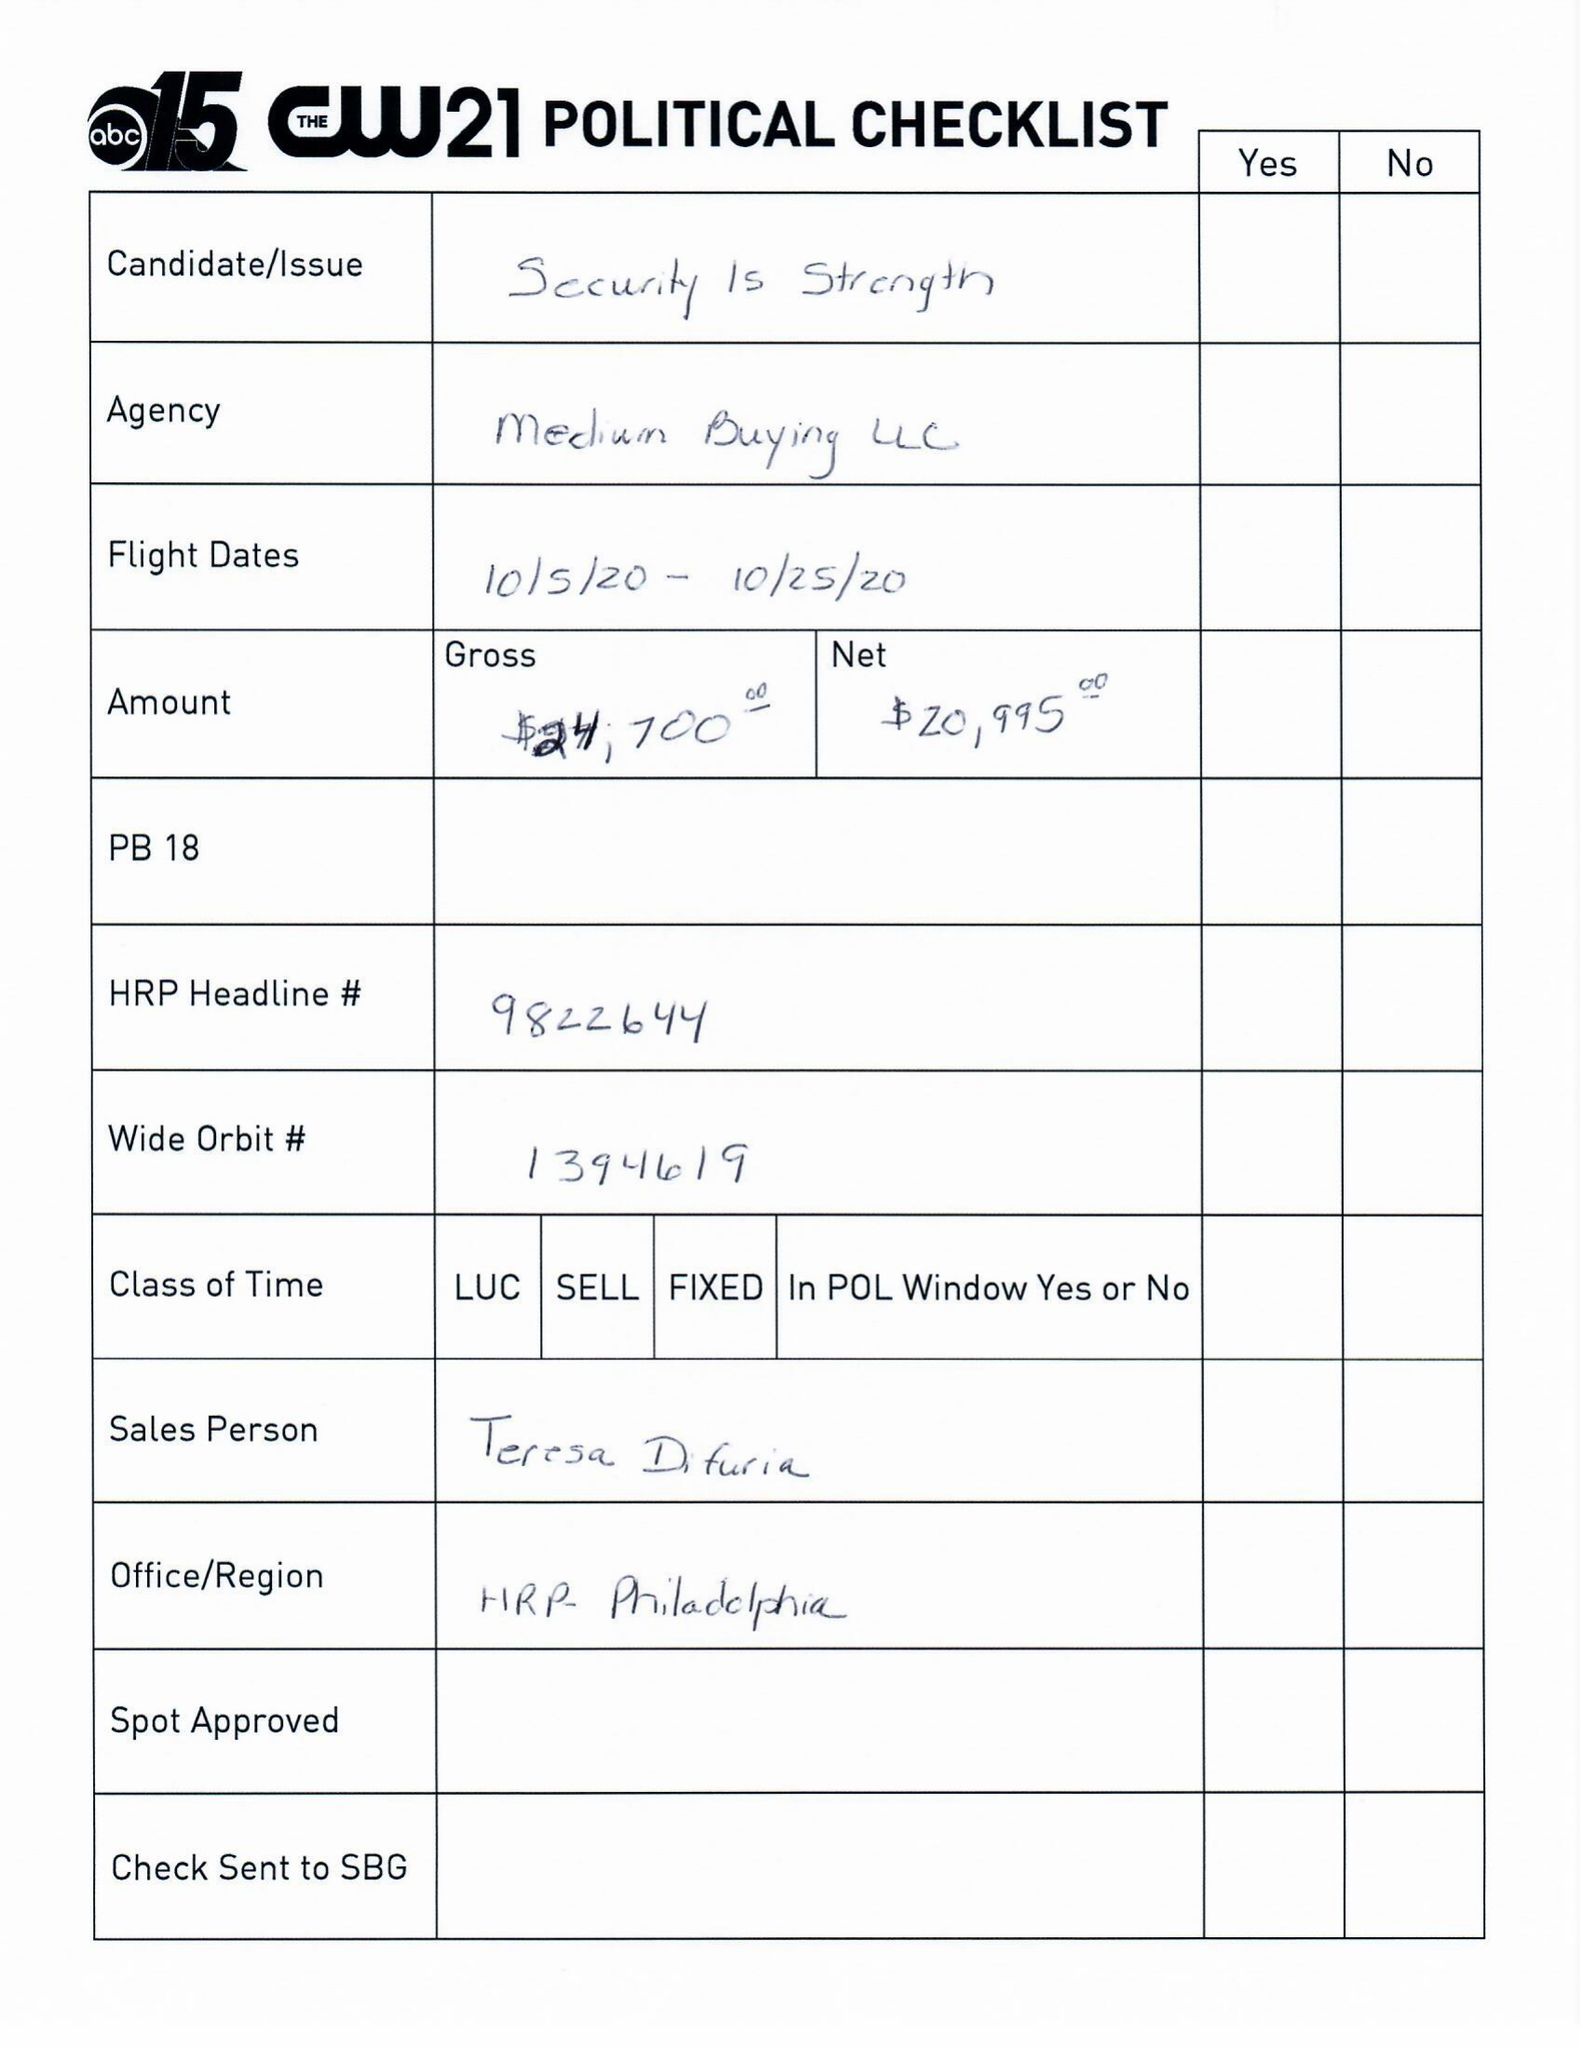What is the value for the gross_amount?
Answer the question using a single word or phrase. 24700.00 